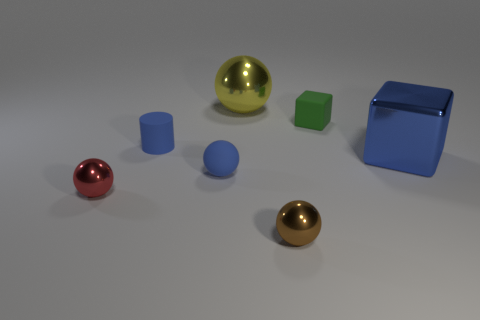Subtract all red metallic balls. How many balls are left? 3 Subtract 1 spheres. How many spheres are left? 3 Subtract all blue balls. How many balls are left? 3 Subtract all gray spheres. Subtract all brown cylinders. How many spheres are left? 4 Add 3 yellow cubes. How many objects exist? 10 Subtract all cylinders. How many objects are left? 6 Add 3 big shiny balls. How many big shiny balls are left? 4 Add 7 large purple rubber balls. How many large purple rubber balls exist? 7 Subtract 0 gray cubes. How many objects are left? 7 Subtract all yellow things. Subtract all red spheres. How many objects are left? 5 